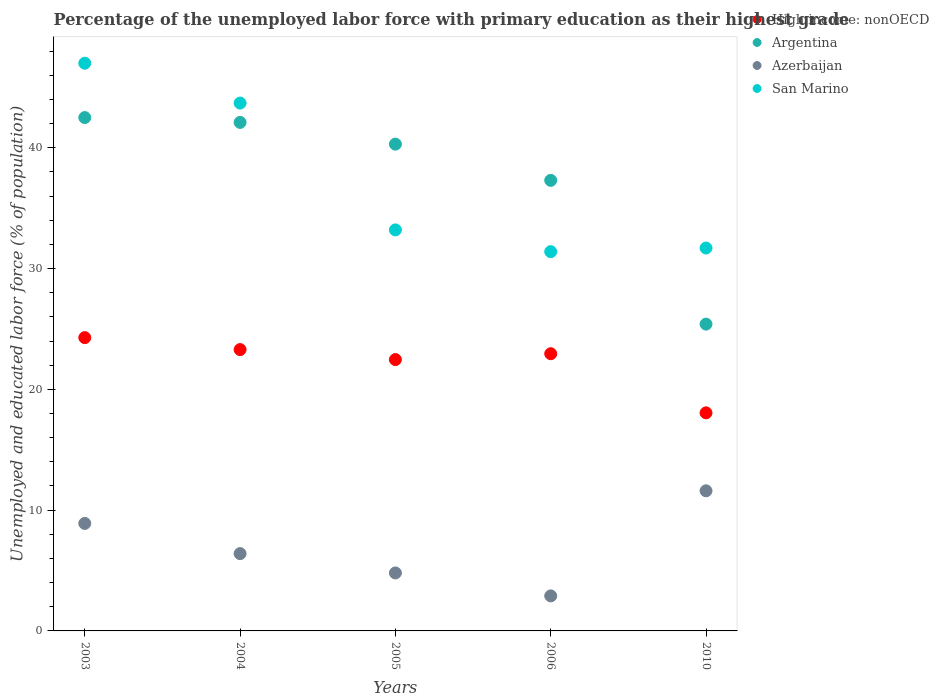How many different coloured dotlines are there?
Your answer should be compact. 4. What is the percentage of the unemployed labor force with primary education in High income: nonOECD in 2006?
Give a very brief answer. 22.95. Across all years, what is the maximum percentage of the unemployed labor force with primary education in Argentina?
Your response must be concise. 42.5. Across all years, what is the minimum percentage of the unemployed labor force with primary education in High income: nonOECD?
Offer a terse response. 18.05. What is the total percentage of the unemployed labor force with primary education in High income: nonOECD in the graph?
Provide a short and direct response. 111.04. What is the difference between the percentage of the unemployed labor force with primary education in San Marino in 2004 and that in 2006?
Provide a succinct answer. 12.3. What is the difference between the percentage of the unemployed labor force with primary education in High income: nonOECD in 2004 and the percentage of the unemployed labor force with primary education in San Marino in 2010?
Provide a short and direct response. -8.41. What is the average percentage of the unemployed labor force with primary education in Argentina per year?
Give a very brief answer. 37.52. In the year 2003, what is the difference between the percentage of the unemployed labor force with primary education in Argentina and percentage of the unemployed labor force with primary education in Azerbaijan?
Make the answer very short. 33.6. In how many years, is the percentage of the unemployed labor force with primary education in Azerbaijan greater than 40 %?
Provide a short and direct response. 0. What is the ratio of the percentage of the unemployed labor force with primary education in High income: nonOECD in 2003 to that in 2006?
Provide a short and direct response. 1.06. Is the percentage of the unemployed labor force with primary education in High income: nonOECD in 2005 less than that in 2010?
Your response must be concise. No. What is the difference between the highest and the second highest percentage of the unemployed labor force with primary education in Azerbaijan?
Offer a very short reply. 2.7. What is the difference between the highest and the lowest percentage of the unemployed labor force with primary education in Argentina?
Your response must be concise. 17.1. In how many years, is the percentage of the unemployed labor force with primary education in Azerbaijan greater than the average percentage of the unemployed labor force with primary education in Azerbaijan taken over all years?
Your answer should be compact. 2. Is the sum of the percentage of the unemployed labor force with primary education in Argentina in 2004 and 2006 greater than the maximum percentage of the unemployed labor force with primary education in High income: nonOECD across all years?
Keep it short and to the point. Yes. Is the percentage of the unemployed labor force with primary education in Azerbaijan strictly greater than the percentage of the unemployed labor force with primary education in High income: nonOECD over the years?
Ensure brevity in your answer.  No. How many dotlines are there?
Your response must be concise. 4. What is the difference between two consecutive major ticks on the Y-axis?
Offer a very short reply. 10. Are the values on the major ticks of Y-axis written in scientific E-notation?
Provide a succinct answer. No. Where does the legend appear in the graph?
Give a very brief answer. Top right. How many legend labels are there?
Provide a succinct answer. 4. What is the title of the graph?
Offer a very short reply. Percentage of the unemployed labor force with primary education as their highest grade. Does "Cayman Islands" appear as one of the legend labels in the graph?
Make the answer very short. No. What is the label or title of the X-axis?
Ensure brevity in your answer.  Years. What is the label or title of the Y-axis?
Your response must be concise. Unemployed and educated labor force (% of population). What is the Unemployed and educated labor force (% of population) of High income: nonOECD in 2003?
Make the answer very short. 24.28. What is the Unemployed and educated labor force (% of population) of Argentina in 2003?
Provide a short and direct response. 42.5. What is the Unemployed and educated labor force (% of population) in Azerbaijan in 2003?
Offer a very short reply. 8.9. What is the Unemployed and educated labor force (% of population) in High income: nonOECD in 2004?
Your answer should be compact. 23.29. What is the Unemployed and educated labor force (% of population) of Argentina in 2004?
Give a very brief answer. 42.1. What is the Unemployed and educated labor force (% of population) in Azerbaijan in 2004?
Keep it short and to the point. 6.4. What is the Unemployed and educated labor force (% of population) of San Marino in 2004?
Your answer should be very brief. 43.7. What is the Unemployed and educated labor force (% of population) in High income: nonOECD in 2005?
Your response must be concise. 22.46. What is the Unemployed and educated labor force (% of population) in Argentina in 2005?
Your response must be concise. 40.3. What is the Unemployed and educated labor force (% of population) in Azerbaijan in 2005?
Keep it short and to the point. 4.8. What is the Unemployed and educated labor force (% of population) in San Marino in 2005?
Provide a succinct answer. 33.2. What is the Unemployed and educated labor force (% of population) of High income: nonOECD in 2006?
Make the answer very short. 22.95. What is the Unemployed and educated labor force (% of population) of Argentina in 2006?
Your answer should be very brief. 37.3. What is the Unemployed and educated labor force (% of population) of Azerbaijan in 2006?
Ensure brevity in your answer.  2.9. What is the Unemployed and educated labor force (% of population) in San Marino in 2006?
Offer a very short reply. 31.4. What is the Unemployed and educated labor force (% of population) of High income: nonOECD in 2010?
Your response must be concise. 18.05. What is the Unemployed and educated labor force (% of population) in Argentina in 2010?
Offer a terse response. 25.4. What is the Unemployed and educated labor force (% of population) of Azerbaijan in 2010?
Your response must be concise. 11.6. What is the Unemployed and educated labor force (% of population) of San Marino in 2010?
Your answer should be compact. 31.7. Across all years, what is the maximum Unemployed and educated labor force (% of population) in High income: nonOECD?
Ensure brevity in your answer.  24.28. Across all years, what is the maximum Unemployed and educated labor force (% of population) in Argentina?
Offer a very short reply. 42.5. Across all years, what is the maximum Unemployed and educated labor force (% of population) in Azerbaijan?
Your answer should be very brief. 11.6. Across all years, what is the minimum Unemployed and educated labor force (% of population) in High income: nonOECD?
Provide a short and direct response. 18.05. Across all years, what is the minimum Unemployed and educated labor force (% of population) of Argentina?
Your answer should be compact. 25.4. Across all years, what is the minimum Unemployed and educated labor force (% of population) of Azerbaijan?
Give a very brief answer. 2.9. Across all years, what is the minimum Unemployed and educated labor force (% of population) in San Marino?
Your answer should be very brief. 31.4. What is the total Unemployed and educated labor force (% of population) of High income: nonOECD in the graph?
Your answer should be very brief. 111.04. What is the total Unemployed and educated labor force (% of population) of Argentina in the graph?
Keep it short and to the point. 187.6. What is the total Unemployed and educated labor force (% of population) of Azerbaijan in the graph?
Offer a very short reply. 34.6. What is the total Unemployed and educated labor force (% of population) of San Marino in the graph?
Your answer should be compact. 187. What is the difference between the Unemployed and educated labor force (% of population) in Argentina in 2003 and that in 2004?
Provide a succinct answer. 0.4. What is the difference between the Unemployed and educated labor force (% of population) of High income: nonOECD in 2003 and that in 2005?
Make the answer very short. 1.82. What is the difference between the Unemployed and educated labor force (% of population) in Azerbaijan in 2003 and that in 2005?
Keep it short and to the point. 4.1. What is the difference between the Unemployed and educated labor force (% of population) in High income: nonOECD in 2003 and that in 2006?
Your response must be concise. 1.33. What is the difference between the Unemployed and educated labor force (% of population) in San Marino in 2003 and that in 2006?
Provide a succinct answer. 15.6. What is the difference between the Unemployed and educated labor force (% of population) in High income: nonOECD in 2003 and that in 2010?
Make the answer very short. 6.23. What is the difference between the Unemployed and educated labor force (% of population) of High income: nonOECD in 2004 and that in 2005?
Ensure brevity in your answer.  0.83. What is the difference between the Unemployed and educated labor force (% of population) in Azerbaijan in 2004 and that in 2005?
Your answer should be compact. 1.6. What is the difference between the Unemployed and educated labor force (% of population) of High income: nonOECD in 2004 and that in 2006?
Offer a very short reply. 0.34. What is the difference between the Unemployed and educated labor force (% of population) of Argentina in 2004 and that in 2006?
Provide a succinct answer. 4.8. What is the difference between the Unemployed and educated labor force (% of population) of San Marino in 2004 and that in 2006?
Your answer should be compact. 12.3. What is the difference between the Unemployed and educated labor force (% of population) of High income: nonOECD in 2004 and that in 2010?
Offer a very short reply. 5.24. What is the difference between the Unemployed and educated labor force (% of population) in Argentina in 2004 and that in 2010?
Provide a short and direct response. 16.7. What is the difference between the Unemployed and educated labor force (% of population) of High income: nonOECD in 2005 and that in 2006?
Offer a very short reply. -0.49. What is the difference between the Unemployed and educated labor force (% of population) in Argentina in 2005 and that in 2006?
Provide a short and direct response. 3. What is the difference between the Unemployed and educated labor force (% of population) of High income: nonOECD in 2005 and that in 2010?
Ensure brevity in your answer.  4.41. What is the difference between the Unemployed and educated labor force (% of population) of Azerbaijan in 2005 and that in 2010?
Make the answer very short. -6.8. What is the difference between the Unemployed and educated labor force (% of population) of San Marino in 2005 and that in 2010?
Provide a short and direct response. 1.5. What is the difference between the Unemployed and educated labor force (% of population) of High income: nonOECD in 2006 and that in 2010?
Offer a very short reply. 4.9. What is the difference between the Unemployed and educated labor force (% of population) of Argentina in 2006 and that in 2010?
Ensure brevity in your answer.  11.9. What is the difference between the Unemployed and educated labor force (% of population) of Azerbaijan in 2006 and that in 2010?
Your response must be concise. -8.7. What is the difference between the Unemployed and educated labor force (% of population) of San Marino in 2006 and that in 2010?
Offer a very short reply. -0.3. What is the difference between the Unemployed and educated labor force (% of population) of High income: nonOECD in 2003 and the Unemployed and educated labor force (% of population) of Argentina in 2004?
Your response must be concise. -17.82. What is the difference between the Unemployed and educated labor force (% of population) in High income: nonOECD in 2003 and the Unemployed and educated labor force (% of population) in Azerbaijan in 2004?
Your answer should be compact. 17.88. What is the difference between the Unemployed and educated labor force (% of population) in High income: nonOECD in 2003 and the Unemployed and educated labor force (% of population) in San Marino in 2004?
Your response must be concise. -19.42. What is the difference between the Unemployed and educated labor force (% of population) of Argentina in 2003 and the Unemployed and educated labor force (% of population) of Azerbaijan in 2004?
Keep it short and to the point. 36.1. What is the difference between the Unemployed and educated labor force (% of population) in Argentina in 2003 and the Unemployed and educated labor force (% of population) in San Marino in 2004?
Provide a succinct answer. -1.2. What is the difference between the Unemployed and educated labor force (% of population) in Azerbaijan in 2003 and the Unemployed and educated labor force (% of population) in San Marino in 2004?
Your response must be concise. -34.8. What is the difference between the Unemployed and educated labor force (% of population) of High income: nonOECD in 2003 and the Unemployed and educated labor force (% of population) of Argentina in 2005?
Provide a succinct answer. -16.02. What is the difference between the Unemployed and educated labor force (% of population) in High income: nonOECD in 2003 and the Unemployed and educated labor force (% of population) in Azerbaijan in 2005?
Provide a short and direct response. 19.48. What is the difference between the Unemployed and educated labor force (% of population) in High income: nonOECD in 2003 and the Unemployed and educated labor force (% of population) in San Marino in 2005?
Make the answer very short. -8.92. What is the difference between the Unemployed and educated labor force (% of population) in Argentina in 2003 and the Unemployed and educated labor force (% of population) in Azerbaijan in 2005?
Give a very brief answer. 37.7. What is the difference between the Unemployed and educated labor force (% of population) of Azerbaijan in 2003 and the Unemployed and educated labor force (% of population) of San Marino in 2005?
Keep it short and to the point. -24.3. What is the difference between the Unemployed and educated labor force (% of population) in High income: nonOECD in 2003 and the Unemployed and educated labor force (% of population) in Argentina in 2006?
Ensure brevity in your answer.  -13.02. What is the difference between the Unemployed and educated labor force (% of population) in High income: nonOECD in 2003 and the Unemployed and educated labor force (% of population) in Azerbaijan in 2006?
Offer a terse response. 21.38. What is the difference between the Unemployed and educated labor force (% of population) in High income: nonOECD in 2003 and the Unemployed and educated labor force (% of population) in San Marino in 2006?
Ensure brevity in your answer.  -7.12. What is the difference between the Unemployed and educated labor force (% of population) of Argentina in 2003 and the Unemployed and educated labor force (% of population) of Azerbaijan in 2006?
Your answer should be compact. 39.6. What is the difference between the Unemployed and educated labor force (% of population) of Argentina in 2003 and the Unemployed and educated labor force (% of population) of San Marino in 2006?
Provide a short and direct response. 11.1. What is the difference between the Unemployed and educated labor force (% of population) of Azerbaijan in 2003 and the Unemployed and educated labor force (% of population) of San Marino in 2006?
Offer a very short reply. -22.5. What is the difference between the Unemployed and educated labor force (% of population) of High income: nonOECD in 2003 and the Unemployed and educated labor force (% of population) of Argentina in 2010?
Offer a very short reply. -1.12. What is the difference between the Unemployed and educated labor force (% of population) in High income: nonOECD in 2003 and the Unemployed and educated labor force (% of population) in Azerbaijan in 2010?
Make the answer very short. 12.68. What is the difference between the Unemployed and educated labor force (% of population) of High income: nonOECD in 2003 and the Unemployed and educated labor force (% of population) of San Marino in 2010?
Offer a very short reply. -7.42. What is the difference between the Unemployed and educated labor force (% of population) of Argentina in 2003 and the Unemployed and educated labor force (% of population) of Azerbaijan in 2010?
Keep it short and to the point. 30.9. What is the difference between the Unemployed and educated labor force (% of population) of Azerbaijan in 2003 and the Unemployed and educated labor force (% of population) of San Marino in 2010?
Your answer should be compact. -22.8. What is the difference between the Unemployed and educated labor force (% of population) in High income: nonOECD in 2004 and the Unemployed and educated labor force (% of population) in Argentina in 2005?
Keep it short and to the point. -17.01. What is the difference between the Unemployed and educated labor force (% of population) of High income: nonOECD in 2004 and the Unemployed and educated labor force (% of population) of Azerbaijan in 2005?
Offer a terse response. 18.49. What is the difference between the Unemployed and educated labor force (% of population) in High income: nonOECD in 2004 and the Unemployed and educated labor force (% of population) in San Marino in 2005?
Keep it short and to the point. -9.91. What is the difference between the Unemployed and educated labor force (% of population) of Argentina in 2004 and the Unemployed and educated labor force (% of population) of Azerbaijan in 2005?
Your answer should be very brief. 37.3. What is the difference between the Unemployed and educated labor force (% of population) of Argentina in 2004 and the Unemployed and educated labor force (% of population) of San Marino in 2005?
Make the answer very short. 8.9. What is the difference between the Unemployed and educated labor force (% of population) of Azerbaijan in 2004 and the Unemployed and educated labor force (% of population) of San Marino in 2005?
Provide a succinct answer. -26.8. What is the difference between the Unemployed and educated labor force (% of population) in High income: nonOECD in 2004 and the Unemployed and educated labor force (% of population) in Argentina in 2006?
Provide a short and direct response. -14.01. What is the difference between the Unemployed and educated labor force (% of population) in High income: nonOECD in 2004 and the Unemployed and educated labor force (% of population) in Azerbaijan in 2006?
Your answer should be compact. 20.39. What is the difference between the Unemployed and educated labor force (% of population) of High income: nonOECD in 2004 and the Unemployed and educated labor force (% of population) of San Marino in 2006?
Offer a terse response. -8.11. What is the difference between the Unemployed and educated labor force (% of population) of Argentina in 2004 and the Unemployed and educated labor force (% of population) of Azerbaijan in 2006?
Provide a short and direct response. 39.2. What is the difference between the Unemployed and educated labor force (% of population) of Azerbaijan in 2004 and the Unemployed and educated labor force (% of population) of San Marino in 2006?
Your answer should be compact. -25. What is the difference between the Unemployed and educated labor force (% of population) in High income: nonOECD in 2004 and the Unemployed and educated labor force (% of population) in Argentina in 2010?
Your response must be concise. -2.11. What is the difference between the Unemployed and educated labor force (% of population) in High income: nonOECD in 2004 and the Unemployed and educated labor force (% of population) in Azerbaijan in 2010?
Your answer should be compact. 11.69. What is the difference between the Unemployed and educated labor force (% of population) in High income: nonOECD in 2004 and the Unemployed and educated labor force (% of population) in San Marino in 2010?
Provide a short and direct response. -8.41. What is the difference between the Unemployed and educated labor force (% of population) of Argentina in 2004 and the Unemployed and educated labor force (% of population) of Azerbaijan in 2010?
Your response must be concise. 30.5. What is the difference between the Unemployed and educated labor force (% of population) in Azerbaijan in 2004 and the Unemployed and educated labor force (% of population) in San Marino in 2010?
Make the answer very short. -25.3. What is the difference between the Unemployed and educated labor force (% of population) in High income: nonOECD in 2005 and the Unemployed and educated labor force (% of population) in Argentina in 2006?
Your response must be concise. -14.84. What is the difference between the Unemployed and educated labor force (% of population) in High income: nonOECD in 2005 and the Unemployed and educated labor force (% of population) in Azerbaijan in 2006?
Your answer should be very brief. 19.56. What is the difference between the Unemployed and educated labor force (% of population) of High income: nonOECD in 2005 and the Unemployed and educated labor force (% of population) of San Marino in 2006?
Give a very brief answer. -8.94. What is the difference between the Unemployed and educated labor force (% of population) of Argentina in 2005 and the Unemployed and educated labor force (% of population) of Azerbaijan in 2006?
Keep it short and to the point. 37.4. What is the difference between the Unemployed and educated labor force (% of population) of Argentina in 2005 and the Unemployed and educated labor force (% of population) of San Marino in 2006?
Your answer should be very brief. 8.9. What is the difference between the Unemployed and educated labor force (% of population) of Azerbaijan in 2005 and the Unemployed and educated labor force (% of population) of San Marino in 2006?
Keep it short and to the point. -26.6. What is the difference between the Unemployed and educated labor force (% of population) in High income: nonOECD in 2005 and the Unemployed and educated labor force (% of population) in Argentina in 2010?
Ensure brevity in your answer.  -2.94. What is the difference between the Unemployed and educated labor force (% of population) of High income: nonOECD in 2005 and the Unemployed and educated labor force (% of population) of Azerbaijan in 2010?
Ensure brevity in your answer.  10.86. What is the difference between the Unemployed and educated labor force (% of population) in High income: nonOECD in 2005 and the Unemployed and educated labor force (% of population) in San Marino in 2010?
Keep it short and to the point. -9.24. What is the difference between the Unemployed and educated labor force (% of population) of Argentina in 2005 and the Unemployed and educated labor force (% of population) of Azerbaijan in 2010?
Your answer should be very brief. 28.7. What is the difference between the Unemployed and educated labor force (% of population) of Azerbaijan in 2005 and the Unemployed and educated labor force (% of population) of San Marino in 2010?
Offer a very short reply. -26.9. What is the difference between the Unemployed and educated labor force (% of population) in High income: nonOECD in 2006 and the Unemployed and educated labor force (% of population) in Argentina in 2010?
Keep it short and to the point. -2.45. What is the difference between the Unemployed and educated labor force (% of population) of High income: nonOECD in 2006 and the Unemployed and educated labor force (% of population) of Azerbaijan in 2010?
Keep it short and to the point. 11.35. What is the difference between the Unemployed and educated labor force (% of population) in High income: nonOECD in 2006 and the Unemployed and educated labor force (% of population) in San Marino in 2010?
Your response must be concise. -8.75. What is the difference between the Unemployed and educated labor force (% of population) of Argentina in 2006 and the Unemployed and educated labor force (% of population) of Azerbaijan in 2010?
Offer a terse response. 25.7. What is the difference between the Unemployed and educated labor force (% of population) of Argentina in 2006 and the Unemployed and educated labor force (% of population) of San Marino in 2010?
Ensure brevity in your answer.  5.6. What is the difference between the Unemployed and educated labor force (% of population) in Azerbaijan in 2006 and the Unemployed and educated labor force (% of population) in San Marino in 2010?
Your response must be concise. -28.8. What is the average Unemployed and educated labor force (% of population) of High income: nonOECD per year?
Your answer should be compact. 22.21. What is the average Unemployed and educated labor force (% of population) in Argentina per year?
Keep it short and to the point. 37.52. What is the average Unemployed and educated labor force (% of population) in Azerbaijan per year?
Provide a short and direct response. 6.92. What is the average Unemployed and educated labor force (% of population) of San Marino per year?
Keep it short and to the point. 37.4. In the year 2003, what is the difference between the Unemployed and educated labor force (% of population) in High income: nonOECD and Unemployed and educated labor force (% of population) in Argentina?
Provide a short and direct response. -18.22. In the year 2003, what is the difference between the Unemployed and educated labor force (% of population) in High income: nonOECD and Unemployed and educated labor force (% of population) in Azerbaijan?
Your answer should be compact. 15.38. In the year 2003, what is the difference between the Unemployed and educated labor force (% of population) in High income: nonOECD and Unemployed and educated labor force (% of population) in San Marino?
Provide a short and direct response. -22.72. In the year 2003, what is the difference between the Unemployed and educated labor force (% of population) of Argentina and Unemployed and educated labor force (% of population) of Azerbaijan?
Give a very brief answer. 33.6. In the year 2003, what is the difference between the Unemployed and educated labor force (% of population) in Azerbaijan and Unemployed and educated labor force (% of population) in San Marino?
Offer a terse response. -38.1. In the year 2004, what is the difference between the Unemployed and educated labor force (% of population) of High income: nonOECD and Unemployed and educated labor force (% of population) of Argentina?
Your response must be concise. -18.81. In the year 2004, what is the difference between the Unemployed and educated labor force (% of population) of High income: nonOECD and Unemployed and educated labor force (% of population) of Azerbaijan?
Your answer should be very brief. 16.89. In the year 2004, what is the difference between the Unemployed and educated labor force (% of population) of High income: nonOECD and Unemployed and educated labor force (% of population) of San Marino?
Offer a very short reply. -20.41. In the year 2004, what is the difference between the Unemployed and educated labor force (% of population) of Argentina and Unemployed and educated labor force (% of population) of Azerbaijan?
Offer a terse response. 35.7. In the year 2004, what is the difference between the Unemployed and educated labor force (% of population) in Argentina and Unemployed and educated labor force (% of population) in San Marino?
Provide a succinct answer. -1.6. In the year 2004, what is the difference between the Unemployed and educated labor force (% of population) in Azerbaijan and Unemployed and educated labor force (% of population) in San Marino?
Your answer should be compact. -37.3. In the year 2005, what is the difference between the Unemployed and educated labor force (% of population) of High income: nonOECD and Unemployed and educated labor force (% of population) of Argentina?
Provide a succinct answer. -17.84. In the year 2005, what is the difference between the Unemployed and educated labor force (% of population) of High income: nonOECD and Unemployed and educated labor force (% of population) of Azerbaijan?
Your response must be concise. 17.66. In the year 2005, what is the difference between the Unemployed and educated labor force (% of population) of High income: nonOECD and Unemployed and educated labor force (% of population) of San Marino?
Your answer should be very brief. -10.74. In the year 2005, what is the difference between the Unemployed and educated labor force (% of population) in Argentina and Unemployed and educated labor force (% of population) in Azerbaijan?
Keep it short and to the point. 35.5. In the year 2005, what is the difference between the Unemployed and educated labor force (% of population) of Azerbaijan and Unemployed and educated labor force (% of population) of San Marino?
Give a very brief answer. -28.4. In the year 2006, what is the difference between the Unemployed and educated labor force (% of population) of High income: nonOECD and Unemployed and educated labor force (% of population) of Argentina?
Your answer should be compact. -14.35. In the year 2006, what is the difference between the Unemployed and educated labor force (% of population) of High income: nonOECD and Unemployed and educated labor force (% of population) of Azerbaijan?
Provide a short and direct response. 20.05. In the year 2006, what is the difference between the Unemployed and educated labor force (% of population) in High income: nonOECD and Unemployed and educated labor force (% of population) in San Marino?
Offer a very short reply. -8.45. In the year 2006, what is the difference between the Unemployed and educated labor force (% of population) in Argentina and Unemployed and educated labor force (% of population) in Azerbaijan?
Give a very brief answer. 34.4. In the year 2006, what is the difference between the Unemployed and educated labor force (% of population) in Argentina and Unemployed and educated labor force (% of population) in San Marino?
Keep it short and to the point. 5.9. In the year 2006, what is the difference between the Unemployed and educated labor force (% of population) of Azerbaijan and Unemployed and educated labor force (% of population) of San Marino?
Ensure brevity in your answer.  -28.5. In the year 2010, what is the difference between the Unemployed and educated labor force (% of population) in High income: nonOECD and Unemployed and educated labor force (% of population) in Argentina?
Your response must be concise. -7.35. In the year 2010, what is the difference between the Unemployed and educated labor force (% of population) of High income: nonOECD and Unemployed and educated labor force (% of population) of Azerbaijan?
Give a very brief answer. 6.45. In the year 2010, what is the difference between the Unemployed and educated labor force (% of population) in High income: nonOECD and Unemployed and educated labor force (% of population) in San Marino?
Your answer should be compact. -13.65. In the year 2010, what is the difference between the Unemployed and educated labor force (% of population) of Azerbaijan and Unemployed and educated labor force (% of population) of San Marino?
Offer a very short reply. -20.1. What is the ratio of the Unemployed and educated labor force (% of population) of High income: nonOECD in 2003 to that in 2004?
Your answer should be compact. 1.04. What is the ratio of the Unemployed and educated labor force (% of population) in Argentina in 2003 to that in 2004?
Your response must be concise. 1.01. What is the ratio of the Unemployed and educated labor force (% of population) of Azerbaijan in 2003 to that in 2004?
Provide a short and direct response. 1.39. What is the ratio of the Unemployed and educated labor force (% of population) in San Marino in 2003 to that in 2004?
Make the answer very short. 1.08. What is the ratio of the Unemployed and educated labor force (% of population) in High income: nonOECD in 2003 to that in 2005?
Provide a short and direct response. 1.08. What is the ratio of the Unemployed and educated labor force (% of population) of Argentina in 2003 to that in 2005?
Make the answer very short. 1.05. What is the ratio of the Unemployed and educated labor force (% of population) of Azerbaijan in 2003 to that in 2005?
Ensure brevity in your answer.  1.85. What is the ratio of the Unemployed and educated labor force (% of population) in San Marino in 2003 to that in 2005?
Your response must be concise. 1.42. What is the ratio of the Unemployed and educated labor force (% of population) in High income: nonOECD in 2003 to that in 2006?
Give a very brief answer. 1.06. What is the ratio of the Unemployed and educated labor force (% of population) in Argentina in 2003 to that in 2006?
Your answer should be compact. 1.14. What is the ratio of the Unemployed and educated labor force (% of population) in Azerbaijan in 2003 to that in 2006?
Offer a terse response. 3.07. What is the ratio of the Unemployed and educated labor force (% of population) in San Marino in 2003 to that in 2006?
Your answer should be compact. 1.5. What is the ratio of the Unemployed and educated labor force (% of population) in High income: nonOECD in 2003 to that in 2010?
Your answer should be compact. 1.34. What is the ratio of the Unemployed and educated labor force (% of population) in Argentina in 2003 to that in 2010?
Your response must be concise. 1.67. What is the ratio of the Unemployed and educated labor force (% of population) in Azerbaijan in 2003 to that in 2010?
Provide a short and direct response. 0.77. What is the ratio of the Unemployed and educated labor force (% of population) in San Marino in 2003 to that in 2010?
Make the answer very short. 1.48. What is the ratio of the Unemployed and educated labor force (% of population) in High income: nonOECD in 2004 to that in 2005?
Provide a short and direct response. 1.04. What is the ratio of the Unemployed and educated labor force (% of population) of Argentina in 2004 to that in 2005?
Your answer should be compact. 1.04. What is the ratio of the Unemployed and educated labor force (% of population) in Azerbaijan in 2004 to that in 2005?
Keep it short and to the point. 1.33. What is the ratio of the Unemployed and educated labor force (% of population) of San Marino in 2004 to that in 2005?
Keep it short and to the point. 1.32. What is the ratio of the Unemployed and educated labor force (% of population) of High income: nonOECD in 2004 to that in 2006?
Offer a very short reply. 1.01. What is the ratio of the Unemployed and educated labor force (% of population) of Argentina in 2004 to that in 2006?
Your answer should be compact. 1.13. What is the ratio of the Unemployed and educated labor force (% of population) in Azerbaijan in 2004 to that in 2006?
Ensure brevity in your answer.  2.21. What is the ratio of the Unemployed and educated labor force (% of population) of San Marino in 2004 to that in 2006?
Provide a short and direct response. 1.39. What is the ratio of the Unemployed and educated labor force (% of population) in High income: nonOECD in 2004 to that in 2010?
Your answer should be compact. 1.29. What is the ratio of the Unemployed and educated labor force (% of population) of Argentina in 2004 to that in 2010?
Your answer should be compact. 1.66. What is the ratio of the Unemployed and educated labor force (% of population) of Azerbaijan in 2004 to that in 2010?
Ensure brevity in your answer.  0.55. What is the ratio of the Unemployed and educated labor force (% of population) in San Marino in 2004 to that in 2010?
Keep it short and to the point. 1.38. What is the ratio of the Unemployed and educated labor force (% of population) in High income: nonOECD in 2005 to that in 2006?
Your answer should be compact. 0.98. What is the ratio of the Unemployed and educated labor force (% of population) of Argentina in 2005 to that in 2006?
Ensure brevity in your answer.  1.08. What is the ratio of the Unemployed and educated labor force (% of population) in Azerbaijan in 2005 to that in 2006?
Your response must be concise. 1.66. What is the ratio of the Unemployed and educated labor force (% of population) in San Marino in 2005 to that in 2006?
Your response must be concise. 1.06. What is the ratio of the Unemployed and educated labor force (% of population) in High income: nonOECD in 2005 to that in 2010?
Offer a very short reply. 1.24. What is the ratio of the Unemployed and educated labor force (% of population) of Argentina in 2005 to that in 2010?
Your answer should be very brief. 1.59. What is the ratio of the Unemployed and educated labor force (% of population) in Azerbaijan in 2005 to that in 2010?
Give a very brief answer. 0.41. What is the ratio of the Unemployed and educated labor force (% of population) in San Marino in 2005 to that in 2010?
Provide a short and direct response. 1.05. What is the ratio of the Unemployed and educated labor force (% of population) in High income: nonOECD in 2006 to that in 2010?
Keep it short and to the point. 1.27. What is the ratio of the Unemployed and educated labor force (% of population) in Argentina in 2006 to that in 2010?
Your answer should be compact. 1.47. What is the ratio of the Unemployed and educated labor force (% of population) in San Marino in 2006 to that in 2010?
Give a very brief answer. 0.99. What is the difference between the highest and the second highest Unemployed and educated labor force (% of population) in High income: nonOECD?
Make the answer very short. 0.99. What is the difference between the highest and the second highest Unemployed and educated labor force (% of population) of Argentina?
Offer a very short reply. 0.4. What is the difference between the highest and the second highest Unemployed and educated labor force (% of population) in San Marino?
Ensure brevity in your answer.  3.3. What is the difference between the highest and the lowest Unemployed and educated labor force (% of population) in High income: nonOECD?
Give a very brief answer. 6.23. What is the difference between the highest and the lowest Unemployed and educated labor force (% of population) in Azerbaijan?
Provide a succinct answer. 8.7. What is the difference between the highest and the lowest Unemployed and educated labor force (% of population) in San Marino?
Your answer should be very brief. 15.6. 